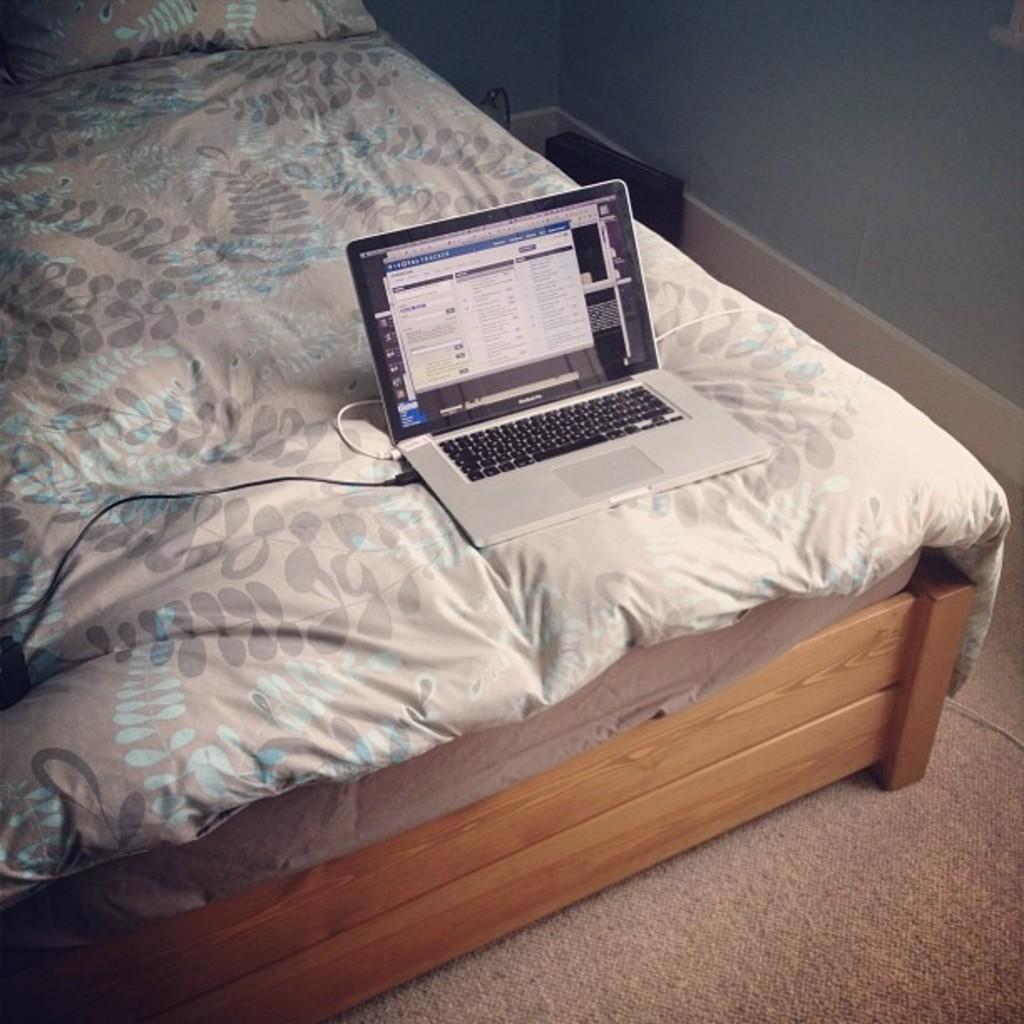Describe this image in one or two sentences. A laptop with wires is kept on the bed. Bed is on a cot. In the background there is a wall. On the floor there is a carpet. 